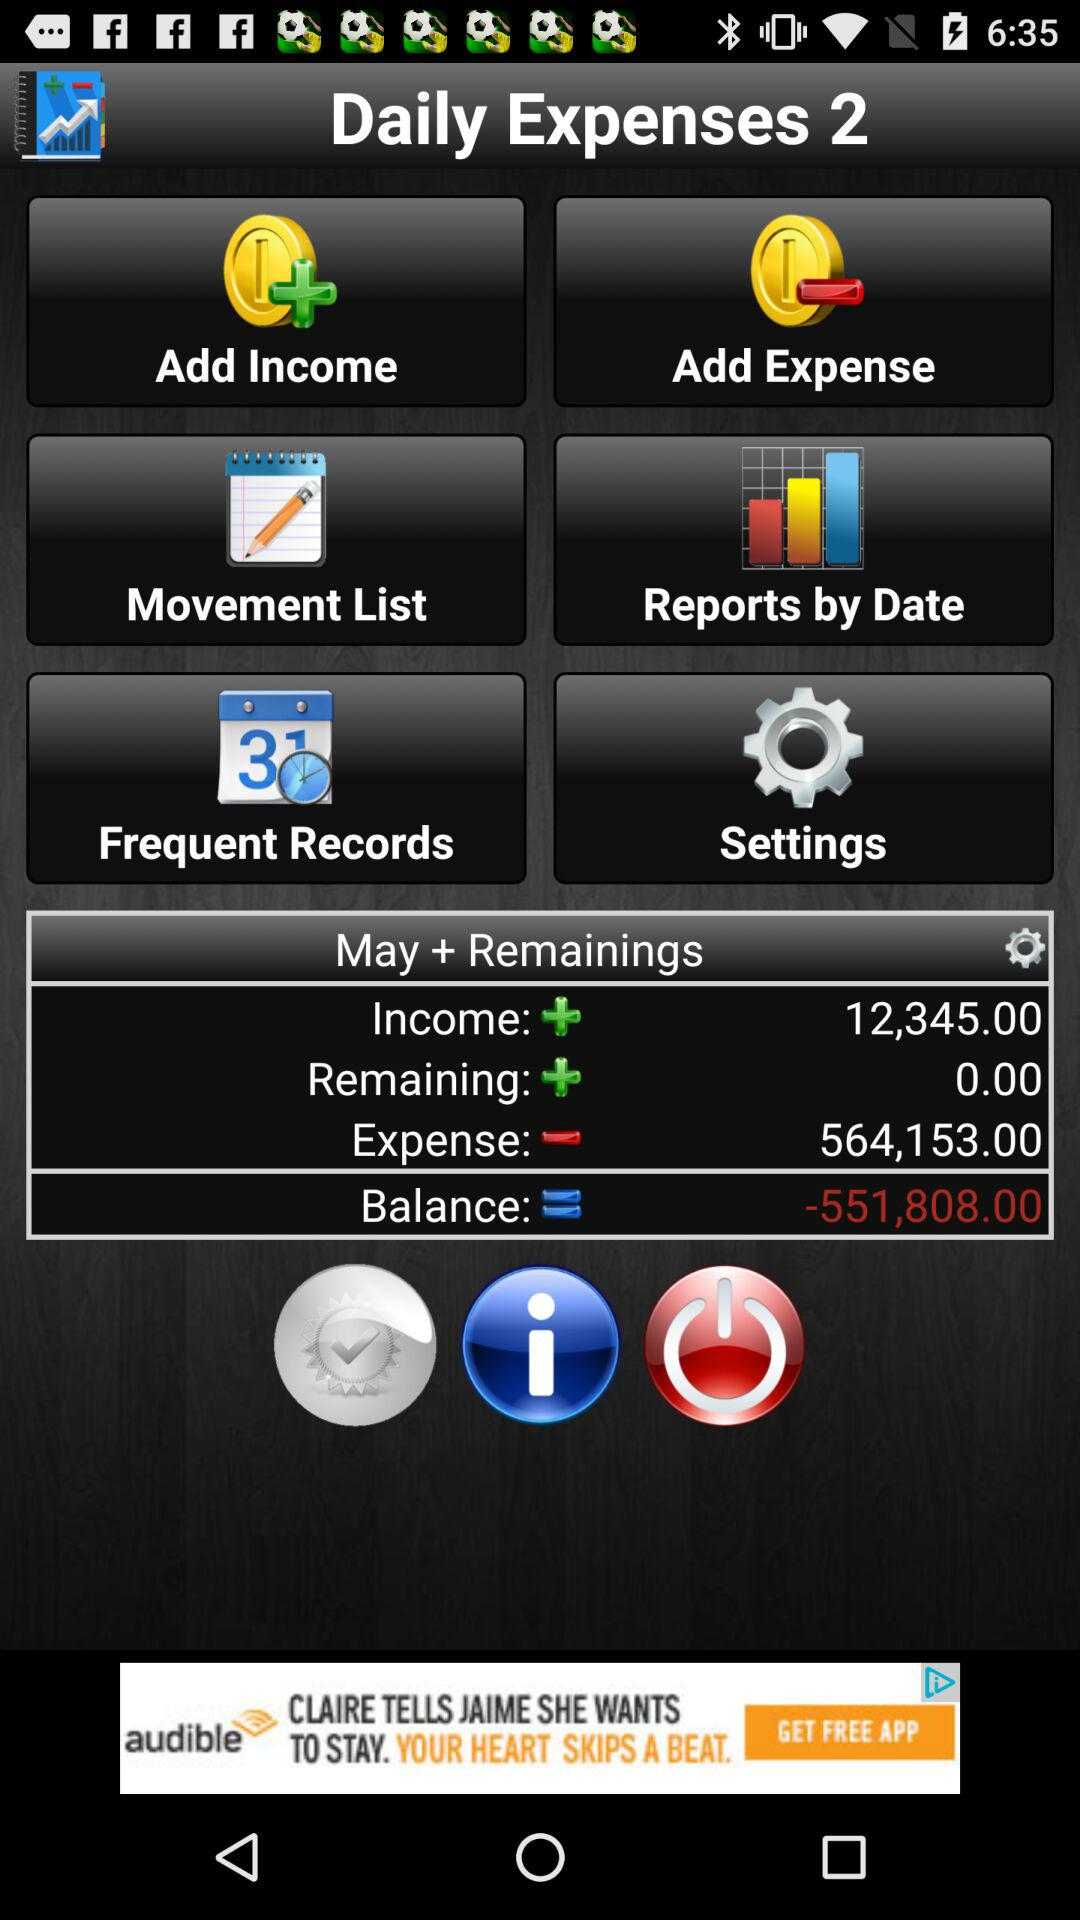What is the balance? The balance is -551,808. 